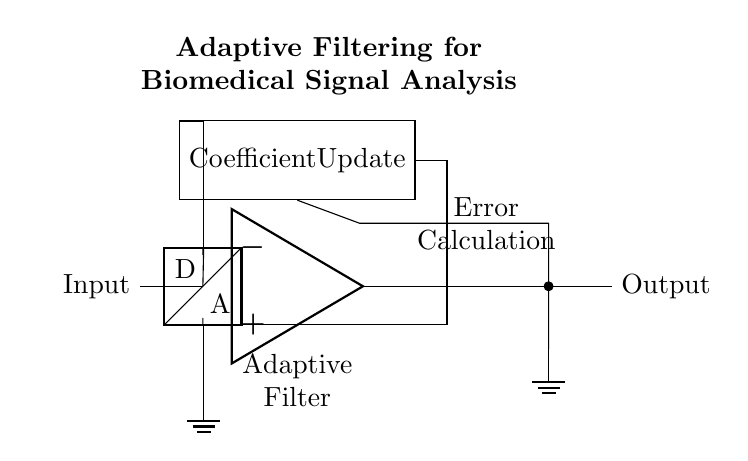What type of filter is represented in the diagram? The diagram shows an adaptive filter, indicated by the presence of an operational amplifier and a coefficient update block.
Answer: Adaptive filter What component connects to the input signal? The input signal connects to an analog-to-digital converter, which is depicted in the left part of the diagram.
Answer: Analog-to-digital converter What is the output of the adaptive filter? The output can be traced from the operational amplifier to the right side of the circuit where the output label is placed.
Answer: Output What process is indicated in the coefficient update block? The coefficient update block indicates a mechanism where the adaptation occurs to the filter coefficients based on the error signal.
Answer: Coefficient updating How does the error calculation process interact with the output? The output of the adaptive filter is fed into an error calculation summing node to compare it with the desired signal, leading to necessary adjustments.
Answer: Feedback interaction 